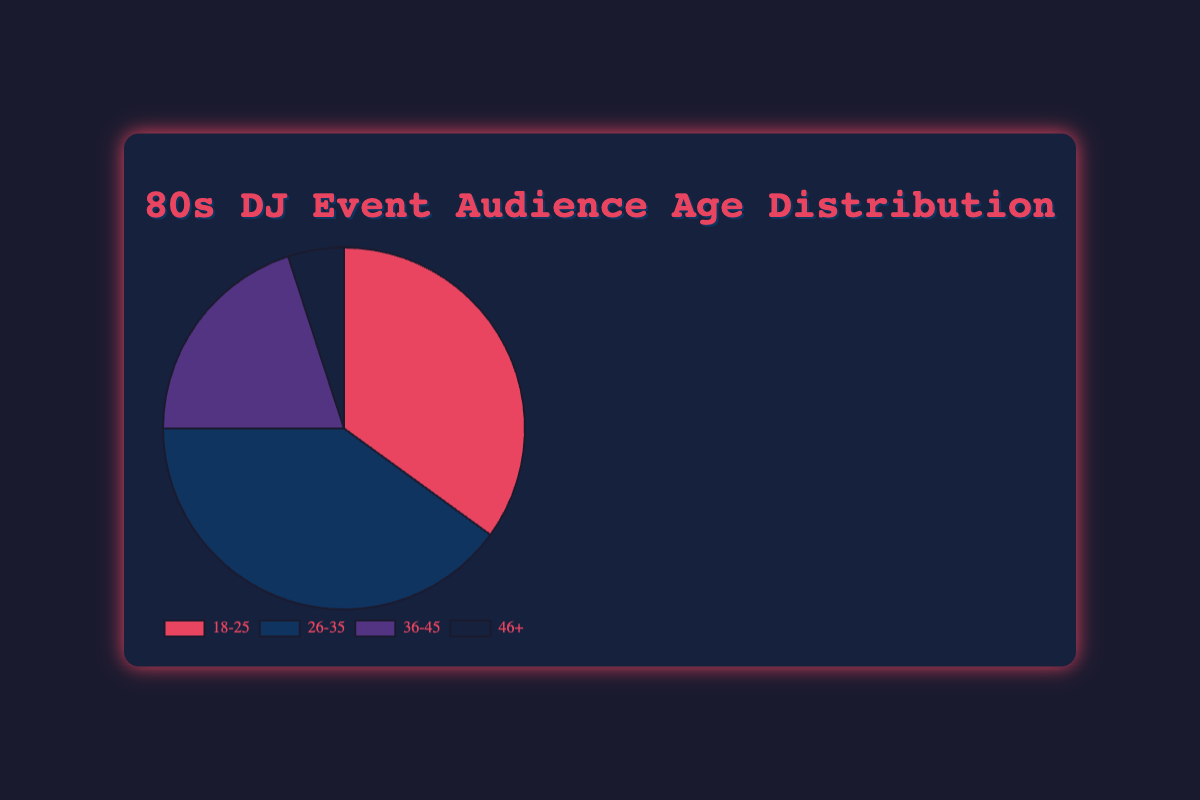What's the largest age group in the audience? By looking at the pie chart, we can identify the largest segment. The "26-35" group covers the largest area of the chart, indicating this segment has the highest percentage.
Answer: 26-35 How many more percent of the audience are in the 18-25 group compared to the 46+ group? The 18-25 group represents 35% of the audience, while the 46+ group accounts for 5%. To find the difference, subtract 5 from 35.
Answer: 30 What percent of the audience is 35 years old or younger? Add the percentages of the 18-25 and 26-35 groups. These groups cover 35% and 40% of the audience, respectively. So, 35% + 40% = 75%.
Answer: 75 Which group has the smallest representation in the audience? The smallest segment can be identified visually by the smallest slice of the pie chart. The "46+" group is the smallest with 5%.
Answer: 46+ What's the combined percentage of the 36-45 and 46+ age groups? Add the percentages of both groups. The 36-45 group has 20% and the 46+ group has 5%. So, 20% + 5% = 25%.
Answer: 25 How do the visual colors differentiate the age groups on the chart? Each age group is represented with a distinct color: "18-25" is red, "26-35" is blue, "36-45" is purple, and "46+" is dark blue.
Answer: Different colors (red, blue, purple, dark blue) Is the 26-35 age group larger or smaller than the 18-25 and 36-45 groups combined? The 26-35 group represents 40%, while the sum of the 18-25 (35%) and 36-45 (20%) groups is 55%. 40% < 55%, so the 26-35 group is smaller.
Answer: Smaller What visual cue helps in identifying the border of each segment? Each segment is outlined with a border to distinguish between different age groups, helping in visual separation of the categories.
Answer: Border What fraction of the audience is aged 26-45? Add the percentages of the "26-35" and "36-45" groups. They represent 40% and 20% respectively, summing to 60%.
Answer: 60% 